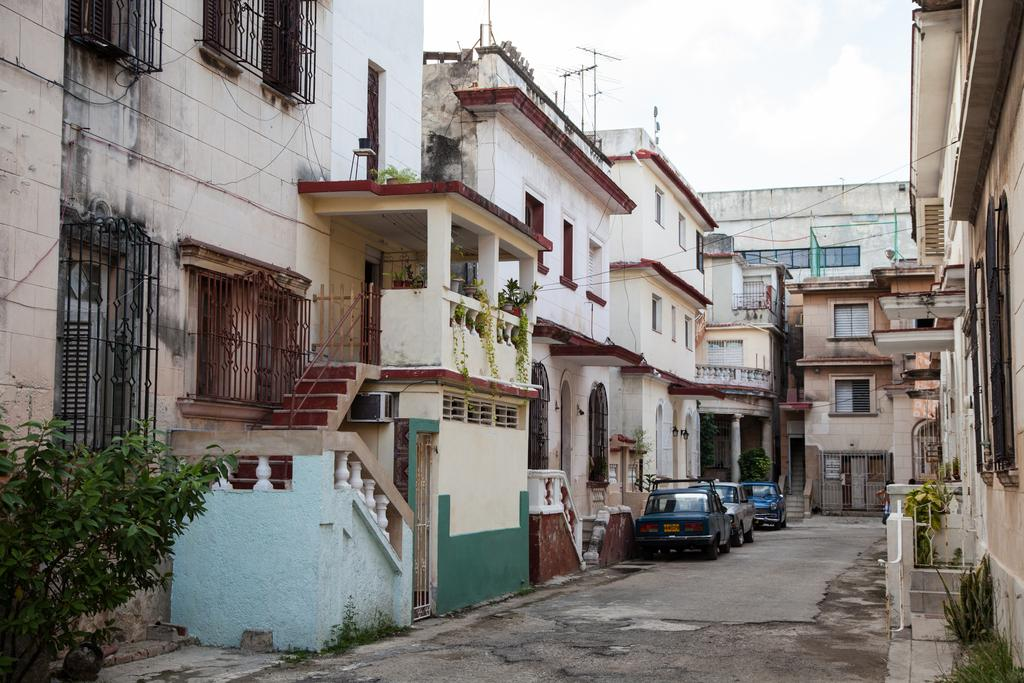What type of structures can be seen in the image? There are houses in the image. Are there any architectural features visible in the image? Yes, there are stairs in the image. What type of vegetation is present in the image? There are plants in front of the houses. What can be seen in the windows of the houses? There are windows in the image. What is parked in front of the houses? There are vehicles parked in front of the houses. What type of milk is being delivered to the houses in the image? There is no milk or delivery service present in the image. What is the engine model of the vehicles parked in front of the houses? There is no information about the engine model of the vehicles in the image. 